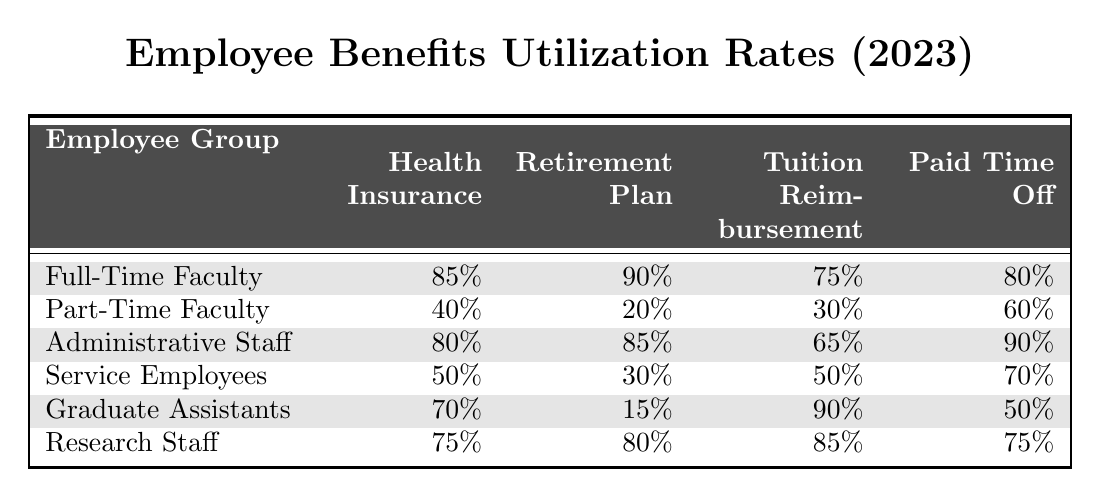What is the Health Insurance Utilization Rate for Full-Time Faculty? The table indicates that the Health Insurance Utilization Rate for Full-Time Faculty is 85%.
Answer: 85% Which employee group has the highest Paid Time Off Utilization Rate? According to the table, the Administrative Staff have the highest Paid Time Off Utilization Rate at 90%.
Answer: Administrative Staff What is the average Tuition Reimbursement Utilization Rate across all employee groups? To find the average, sum the individual rates: (75 + 30 + 65 + 50 + 90 + 85) = 395. There are 6 groups, so the average is 395/6 = 65.83%.
Answer: 65.83% Is the Retirement Plan Utilization Rate for Graduate Assistants higher than that for Service Employees? The table shows that Graduate Assistants have a Retirement Plan Utilization Rate of 15%, while Service Employees have 30%. Since 15% is less than 30%, the answer is no.
Answer: No What is the difference in Health Insurance Utilization Rates between Full-Time Faculty and Part-Time Faculty? The Health Insurance Utilization Rate for Full-Time Faculty is 85%, and for Part-Time Faculty, it is 40%. The difference is 85% - 40% = 45%.
Answer: 45% Which group has the lowest Retirement Plan Utilization Rate, and what is that rate? The lowest Retirement Plan Utilization Rate in the table is for Graduate Assistants at 15%.
Answer: Graduate Assistants, 15% What percentage of Part-Time Faculty utilize Tuition Reimbursement? The table states that Tuition Reimbursement Utilization Rate for Part-Time Faculty is 30%.
Answer: 30% How many employee groups have a Health Insurance Utilization Rate greater than 70%? The groups with rates greater than 70% are Full-Time Faculty (85%), Administrative Staff (80%), and Research Staff (75%). Thus, there are 3 groups.
Answer: 3 In terms of Paid Time Off, which employee group has utilized their benefits the least, and what is the rate? The Service Employees have a Paid Time Off Utilization Rate of 70%, which is the lowest when compared to the other groups.
Answer: Service Employees, 70% Can we conclude that Administrative Staff utilize their Retirement Plan more than Graduate Assistants? Yes, Administrative Staff have a Retirement Plan Utilization Rate of 85%, while Graduate Assistants have only 15%. Thus, Administrative Staff do utilize it more.
Answer: Yes 